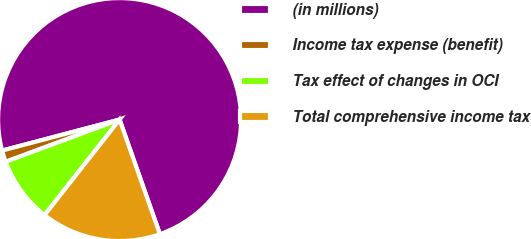<chart> <loc_0><loc_0><loc_500><loc_500><pie_chart><fcel>(in millions)<fcel>Income tax expense (benefit)<fcel>Tax effect of changes in OCI<fcel>Total comprehensive income tax<nl><fcel>73.73%<fcel>1.54%<fcel>8.76%<fcel>15.98%<nl></chart> 